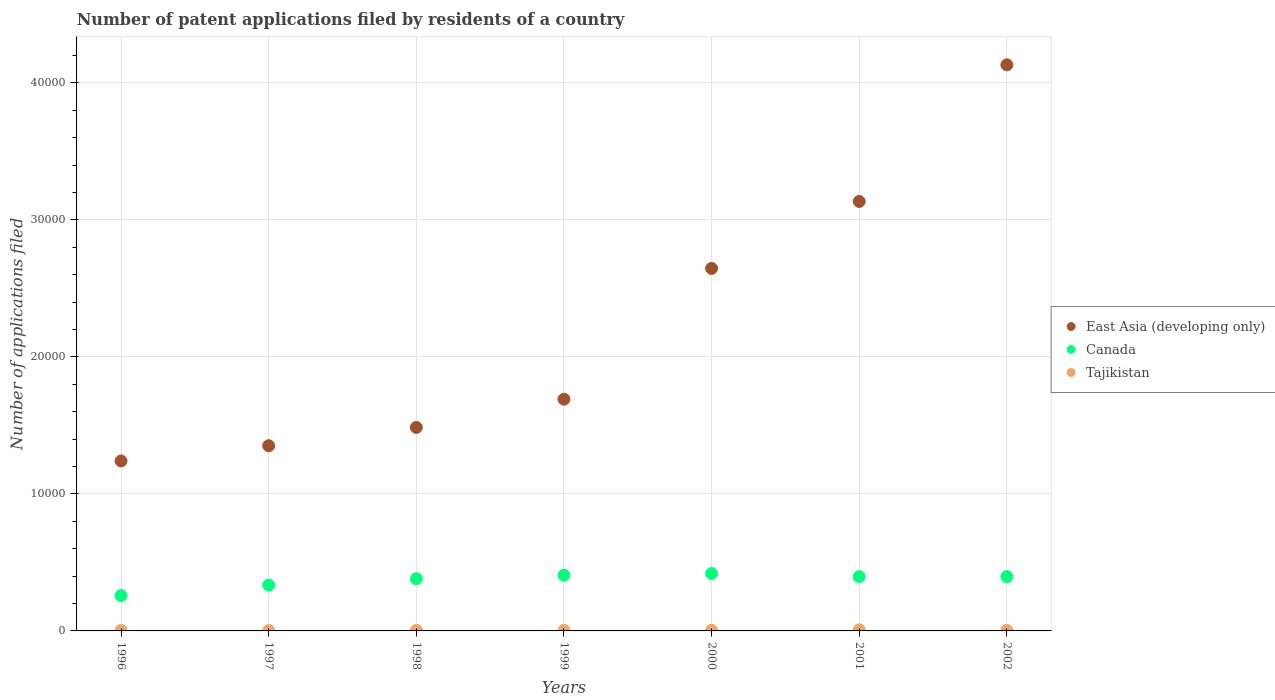How many different coloured dotlines are there?
Provide a succinct answer. 3. Is the number of dotlines equal to the number of legend labels?
Give a very brief answer. Yes. Across all years, what is the maximum number of applications filed in East Asia (developing only)?
Offer a terse response. 4.13e+04. Across all years, what is the minimum number of applications filed in East Asia (developing only)?
Offer a terse response. 1.24e+04. What is the total number of applications filed in Tajikistan in the graph?
Your answer should be very brief. 295. What is the difference between the number of applications filed in East Asia (developing only) in 1996 and that in 2001?
Provide a short and direct response. -1.89e+04. What is the difference between the number of applications filed in Tajikistan in 1997 and the number of applications filed in East Asia (developing only) in 1996?
Provide a succinct answer. -1.24e+04. What is the average number of applications filed in East Asia (developing only) per year?
Your response must be concise. 2.24e+04. In the year 1999, what is the difference between the number of applications filed in Tajikistan and number of applications filed in Canada?
Offer a terse response. -4023. What is the ratio of the number of applications filed in Canada in 1998 to that in 2001?
Your answer should be very brief. 0.96. Is the number of applications filed in Canada in 2000 less than that in 2002?
Ensure brevity in your answer.  No. What is the difference between the highest and the lowest number of applications filed in Canada?
Make the answer very short. 1604. Does the number of applications filed in Canada monotonically increase over the years?
Keep it short and to the point. No. Is the number of applications filed in Canada strictly greater than the number of applications filed in Tajikistan over the years?
Your answer should be very brief. Yes. Is the number of applications filed in East Asia (developing only) strictly less than the number of applications filed in Canada over the years?
Your response must be concise. No. How many dotlines are there?
Your response must be concise. 3. How many years are there in the graph?
Provide a succinct answer. 7. What is the difference between two consecutive major ticks on the Y-axis?
Keep it short and to the point. 10000. Are the values on the major ticks of Y-axis written in scientific E-notation?
Offer a very short reply. No. Does the graph contain grids?
Ensure brevity in your answer.  Yes. Where does the legend appear in the graph?
Offer a terse response. Center right. How many legend labels are there?
Give a very brief answer. 3. What is the title of the graph?
Your answer should be compact. Number of patent applications filed by residents of a country. What is the label or title of the X-axis?
Provide a succinct answer. Years. What is the label or title of the Y-axis?
Your answer should be very brief. Number of applications filed. What is the Number of applications filed in East Asia (developing only) in 1996?
Make the answer very short. 1.24e+04. What is the Number of applications filed of Canada in 1996?
Provide a succinct answer. 2583. What is the Number of applications filed of East Asia (developing only) in 1997?
Provide a short and direct response. 1.35e+04. What is the Number of applications filed of Canada in 1997?
Keep it short and to the point. 3344. What is the Number of applications filed in East Asia (developing only) in 1998?
Ensure brevity in your answer.  1.49e+04. What is the Number of applications filed in Canada in 1998?
Keep it short and to the point. 3809. What is the Number of applications filed of Tajikistan in 1998?
Your answer should be compact. 37. What is the Number of applications filed in East Asia (developing only) in 1999?
Offer a terse response. 1.69e+04. What is the Number of applications filed of Canada in 1999?
Keep it short and to the point. 4061. What is the Number of applications filed in Tajikistan in 1999?
Give a very brief answer. 38. What is the Number of applications filed in East Asia (developing only) in 2000?
Provide a succinct answer. 2.65e+04. What is the Number of applications filed in Canada in 2000?
Provide a succinct answer. 4187. What is the Number of applications filed in East Asia (developing only) in 2001?
Provide a succinct answer. 3.13e+04. What is the Number of applications filed in Canada in 2001?
Your answer should be very brief. 3963. What is the Number of applications filed in Tajikistan in 2001?
Offer a very short reply. 83. What is the Number of applications filed in East Asia (developing only) in 2002?
Ensure brevity in your answer.  4.13e+04. What is the Number of applications filed of Canada in 2002?
Give a very brief answer. 3959. What is the Number of applications filed in Tajikistan in 2002?
Your response must be concise. 39. Across all years, what is the maximum Number of applications filed of East Asia (developing only)?
Give a very brief answer. 4.13e+04. Across all years, what is the maximum Number of applications filed of Canada?
Ensure brevity in your answer.  4187. Across all years, what is the minimum Number of applications filed in East Asia (developing only)?
Provide a short and direct response. 1.24e+04. Across all years, what is the minimum Number of applications filed in Canada?
Your answer should be compact. 2583. Across all years, what is the minimum Number of applications filed in Tajikistan?
Ensure brevity in your answer.  23. What is the total Number of applications filed in East Asia (developing only) in the graph?
Provide a short and direct response. 1.57e+05. What is the total Number of applications filed of Canada in the graph?
Your response must be concise. 2.59e+04. What is the total Number of applications filed of Tajikistan in the graph?
Ensure brevity in your answer.  295. What is the difference between the Number of applications filed of East Asia (developing only) in 1996 and that in 1997?
Your answer should be compact. -1111. What is the difference between the Number of applications filed in Canada in 1996 and that in 1997?
Ensure brevity in your answer.  -761. What is the difference between the Number of applications filed in East Asia (developing only) in 1996 and that in 1998?
Your answer should be compact. -2446. What is the difference between the Number of applications filed in Canada in 1996 and that in 1998?
Your response must be concise. -1226. What is the difference between the Number of applications filed of Tajikistan in 1996 and that in 1998?
Your response must be concise. -7. What is the difference between the Number of applications filed in East Asia (developing only) in 1996 and that in 1999?
Your response must be concise. -4507. What is the difference between the Number of applications filed in Canada in 1996 and that in 1999?
Your answer should be very brief. -1478. What is the difference between the Number of applications filed in Tajikistan in 1996 and that in 1999?
Provide a short and direct response. -8. What is the difference between the Number of applications filed in East Asia (developing only) in 1996 and that in 2000?
Offer a very short reply. -1.41e+04. What is the difference between the Number of applications filed of Canada in 1996 and that in 2000?
Offer a terse response. -1604. What is the difference between the Number of applications filed of Tajikistan in 1996 and that in 2000?
Offer a terse response. -15. What is the difference between the Number of applications filed in East Asia (developing only) in 1996 and that in 2001?
Give a very brief answer. -1.89e+04. What is the difference between the Number of applications filed of Canada in 1996 and that in 2001?
Offer a very short reply. -1380. What is the difference between the Number of applications filed of Tajikistan in 1996 and that in 2001?
Make the answer very short. -53. What is the difference between the Number of applications filed of East Asia (developing only) in 1996 and that in 2002?
Provide a succinct answer. -2.89e+04. What is the difference between the Number of applications filed of Canada in 1996 and that in 2002?
Ensure brevity in your answer.  -1376. What is the difference between the Number of applications filed in East Asia (developing only) in 1997 and that in 1998?
Your answer should be compact. -1335. What is the difference between the Number of applications filed of Canada in 1997 and that in 1998?
Offer a terse response. -465. What is the difference between the Number of applications filed of East Asia (developing only) in 1997 and that in 1999?
Ensure brevity in your answer.  -3396. What is the difference between the Number of applications filed in Canada in 1997 and that in 1999?
Your response must be concise. -717. What is the difference between the Number of applications filed of Tajikistan in 1997 and that in 1999?
Provide a short and direct response. -15. What is the difference between the Number of applications filed of East Asia (developing only) in 1997 and that in 2000?
Your response must be concise. -1.29e+04. What is the difference between the Number of applications filed of Canada in 1997 and that in 2000?
Make the answer very short. -843. What is the difference between the Number of applications filed in Tajikistan in 1997 and that in 2000?
Your answer should be compact. -22. What is the difference between the Number of applications filed of East Asia (developing only) in 1997 and that in 2001?
Provide a succinct answer. -1.78e+04. What is the difference between the Number of applications filed in Canada in 1997 and that in 2001?
Provide a succinct answer. -619. What is the difference between the Number of applications filed of Tajikistan in 1997 and that in 2001?
Provide a short and direct response. -60. What is the difference between the Number of applications filed of East Asia (developing only) in 1997 and that in 2002?
Make the answer very short. -2.78e+04. What is the difference between the Number of applications filed in Canada in 1997 and that in 2002?
Provide a short and direct response. -615. What is the difference between the Number of applications filed in Tajikistan in 1997 and that in 2002?
Ensure brevity in your answer.  -16. What is the difference between the Number of applications filed in East Asia (developing only) in 1998 and that in 1999?
Provide a short and direct response. -2061. What is the difference between the Number of applications filed in Canada in 1998 and that in 1999?
Your answer should be very brief. -252. What is the difference between the Number of applications filed in East Asia (developing only) in 1998 and that in 2000?
Provide a short and direct response. -1.16e+04. What is the difference between the Number of applications filed of Canada in 1998 and that in 2000?
Provide a succinct answer. -378. What is the difference between the Number of applications filed of East Asia (developing only) in 1998 and that in 2001?
Your answer should be very brief. -1.65e+04. What is the difference between the Number of applications filed of Canada in 1998 and that in 2001?
Ensure brevity in your answer.  -154. What is the difference between the Number of applications filed in Tajikistan in 1998 and that in 2001?
Keep it short and to the point. -46. What is the difference between the Number of applications filed of East Asia (developing only) in 1998 and that in 2002?
Offer a very short reply. -2.65e+04. What is the difference between the Number of applications filed in Canada in 1998 and that in 2002?
Offer a very short reply. -150. What is the difference between the Number of applications filed in Tajikistan in 1998 and that in 2002?
Provide a short and direct response. -2. What is the difference between the Number of applications filed in East Asia (developing only) in 1999 and that in 2000?
Offer a terse response. -9545. What is the difference between the Number of applications filed in Canada in 1999 and that in 2000?
Your answer should be very brief. -126. What is the difference between the Number of applications filed of Tajikistan in 1999 and that in 2000?
Provide a succinct answer. -7. What is the difference between the Number of applications filed in East Asia (developing only) in 1999 and that in 2001?
Offer a terse response. -1.44e+04. What is the difference between the Number of applications filed in Canada in 1999 and that in 2001?
Your answer should be very brief. 98. What is the difference between the Number of applications filed in Tajikistan in 1999 and that in 2001?
Your answer should be very brief. -45. What is the difference between the Number of applications filed of East Asia (developing only) in 1999 and that in 2002?
Offer a very short reply. -2.44e+04. What is the difference between the Number of applications filed of Canada in 1999 and that in 2002?
Ensure brevity in your answer.  102. What is the difference between the Number of applications filed in East Asia (developing only) in 2000 and that in 2001?
Keep it short and to the point. -4890. What is the difference between the Number of applications filed of Canada in 2000 and that in 2001?
Offer a very short reply. 224. What is the difference between the Number of applications filed of Tajikistan in 2000 and that in 2001?
Offer a very short reply. -38. What is the difference between the Number of applications filed in East Asia (developing only) in 2000 and that in 2002?
Provide a succinct answer. -1.49e+04. What is the difference between the Number of applications filed in Canada in 2000 and that in 2002?
Ensure brevity in your answer.  228. What is the difference between the Number of applications filed in Tajikistan in 2000 and that in 2002?
Your response must be concise. 6. What is the difference between the Number of applications filed of East Asia (developing only) in 2001 and that in 2002?
Your answer should be very brief. -9968. What is the difference between the Number of applications filed in Tajikistan in 2001 and that in 2002?
Your response must be concise. 44. What is the difference between the Number of applications filed of East Asia (developing only) in 1996 and the Number of applications filed of Canada in 1997?
Keep it short and to the point. 9062. What is the difference between the Number of applications filed of East Asia (developing only) in 1996 and the Number of applications filed of Tajikistan in 1997?
Your answer should be compact. 1.24e+04. What is the difference between the Number of applications filed in Canada in 1996 and the Number of applications filed in Tajikistan in 1997?
Provide a short and direct response. 2560. What is the difference between the Number of applications filed in East Asia (developing only) in 1996 and the Number of applications filed in Canada in 1998?
Ensure brevity in your answer.  8597. What is the difference between the Number of applications filed of East Asia (developing only) in 1996 and the Number of applications filed of Tajikistan in 1998?
Ensure brevity in your answer.  1.24e+04. What is the difference between the Number of applications filed of Canada in 1996 and the Number of applications filed of Tajikistan in 1998?
Give a very brief answer. 2546. What is the difference between the Number of applications filed of East Asia (developing only) in 1996 and the Number of applications filed of Canada in 1999?
Your answer should be very brief. 8345. What is the difference between the Number of applications filed of East Asia (developing only) in 1996 and the Number of applications filed of Tajikistan in 1999?
Provide a succinct answer. 1.24e+04. What is the difference between the Number of applications filed in Canada in 1996 and the Number of applications filed in Tajikistan in 1999?
Make the answer very short. 2545. What is the difference between the Number of applications filed of East Asia (developing only) in 1996 and the Number of applications filed of Canada in 2000?
Give a very brief answer. 8219. What is the difference between the Number of applications filed in East Asia (developing only) in 1996 and the Number of applications filed in Tajikistan in 2000?
Your answer should be very brief. 1.24e+04. What is the difference between the Number of applications filed of Canada in 1996 and the Number of applications filed of Tajikistan in 2000?
Offer a terse response. 2538. What is the difference between the Number of applications filed in East Asia (developing only) in 1996 and the Number of applications filed in Canada in 2001?
Your answer should be very brief. 8443. What is the difference between the Number of applications filed in East Asia (developing only) in 1996 and the Number of applications filed in Tajikistan in 2001?
Offer a terse response. 1.23e+04. What is the difference between the Number of applications filed of Canada in 1996 and the Number of applications filed of Tajikistan in 2001?
Your response must be concise. 2500. What is the difference between the Number of applications filed of East Asia (developing only) in 1996 and the Number of applications filed of Canada in 2002?
Your answer should be compact. 8447. What is the difference between the Number of applications filed in East Asia (developing only) in 1996 and the Number of applications filed in Tajikistan in 2002?
Your response must be concise. 1.24e+04. What is the difference between the Number of applications filed of Canada in 1996 and the Number of applications filed of Tajikistan in 2002?
Provide a short and direct response. 2544. What is the difference between the Number of applications filed in East Asia (developing only) in 1997 and the Number of applications filed in Canada in 1998?
Offer a very short reply. 9708. What is the difference between the Number of applications filed of East Asia (developing only) in 1997 and the Number of applications filed of Tajikistan in 1998?
Provide a short and direct response. 1.35e+04. What is the difference between the Number of applications filed in Canada in 1997 and the Number of applications filed in Tajikistan in 1998?
Offer a very short reply. 3307. What is the difference between the Number of applications filed of East Asia (developing only) in 1997 and the Number of applications filed of Canada in 1999?
Give a very brief answer. 9456. What is the difference between the Number of applications filed in East Asia (developing only) in 1997 and the Number of applications filed in Tajikistan in 1999?
Your response must be concise. 1.35e+04. What is the difference between the Number of applications filed of Canada in 1997 and the Number of applications filed of Tajikistan in 1999?
Ensure brevity in your answer.  3306. What is the difference between the Number of applications filed of East Asia (developing only) in 1997 and the Number of applications filed of Canada in 2000?
Give a very brief answer. 9330. What is the difference between the Number of applications filed of East Asia (developing only) in 1997 and the Number of applications filed of Tajikistan in 2000?
Make the answer very short. 1.35e+04. What is the difference between the Number of applications filed of Canada in 1997 and the Number of applications filed of Tajikistan in 2000?
Ensure brevity in your answer.  3299. What is the difference between the Number of applications filed in East Asia (developing only) in 1997 and the Number of applications filed in Canada in 2001?
Your response must be concise. 9554. What is the difference between the Number of applications filed in East Asia (developing only) in 1997 and the Number of applications filed in Tajikistan in 2001?
Your answer should be compact. 1.34e+04. What is the difference between the Number of applications filed in Canada in 1997 and the Number of applications filed in Tajikistan in 2001?
Provide a succinct answer. 3261. What is the difference between the Number of applications filed in East Asia (developing only) in 1997 and the Number of applications filed in Canada in 2002?
Your response must be concise. 9558. What is the difference between the Number of applications filed in East Asia (developing only) in 1997 and the Number of applications filed in Tajikistan in 2002?
Your answer should be compact. 1.35e+04. What is the difference between the Number of applications filed of Canada in 1997 and the Number of applications filed of Tajikistan in 2002?
Make the answer very short. 3305. What is the difference between the Number of applications filed in East Asia (developing only) in 1998 and the Number of applications filed in Canada in 1999?
Keep it short and to the point. 1.08e+04. What is the difference between the Number of applications filed in East Asia (developing only) in 1998 and the Number of applications filed in Tajikistan in 1999?
Ensure brevity in your answer.  1.48e+04. What is the difference between the Number of applications filed in Canada in 1998 and the Number of applications filed in Tajikistan in 1999?
Your answer should be very brief. 3771. What is the difference between the Number of applications filed in East Asia (developing only) in 1998 and the Number of applications filed in Canada in 2000?
Your answer should be compact. 1.07e+04. What is the difference between the Number of applications filed in East Asia (developing only) in 1998 and the Number of applications filed in Tajikistan in 2000?
Offer a terse response. 1.48e+04. What is the difference between the Number of applications filed of Canada in 1998 and the Number of applications filed of Tajikistan in 2000?
Your answer should be very brief. 3764. What is the difference between the Number of applications filed in East Asia (developing only) in 1998 and the Number of applications filed in Canada in 2001?
Give a very brief answer. 1.09e+04. What is the difference between the Number of applications filed in East Asia (developing only) in 1998 and the Number of applications filed in Tajikistan in 2001?
Provide a succinct answer. 1.48e+04. What is the difference between the Number of applications filed of Canada in 1998 and the Number of applications filed of Tajikistan in 2001?
Offer a very short reply. 3726. What is the difference between the Number of applications filed of East Asia (developing only) in 1998 and the Number of applications filed of Canada in 2002?
Give a very brief answer. 1.09e+04. What is the difference between the Number of applications filed of East Asia (developing only) in 1998 and the Number of applications filed of Tajikistan in 2002?
Provide a short and direct response. 1.48e+04. What is the difference between the Number of applications filed in Canada in 1998 and the Number of applications filed in Tajikistan in 2002?
Provide a short and direct response. 3770. What is the difference between the Number of applications filed in East Asia (developing only) in 1999 and the Number of applications filed in Canada in 2000?
Your answer should be very brief. 1.27e+04. What is the difference between the Number of applications filed in East Asia (developing only) in 1999 and the Number of applications filed in Tajikistan in 2000?
Keep it short and to the point. 1.69e+04. What is the difference between the Number of applications filed of Canada in 1999 and the Number of applications filed of Tajikistan in 2000?
Provide a succinct answer. 4016. What is the difference between the Number of applications filed in East Asia (developing only) in 1999 and the Number of applications filed in Canada in 2001?
Your response must be concise. 1.30e+04. What is the difference between the Number of applications filed in East Asia (developing only) in 1999 and the Number of applications filed in Tajikistan in 2001?
Ensure brevity in your answer.  1.68e+04. What is the difference between the Number of applications filed of Canada in 1999 and the Number of applications filed of Tajikistan in 2001?
Your answer should be very brief. 3978. What is the difference between the Number of applications filed in East Asia (developing only) in 1999 and the Number of applications filed in Canada in 2002?
Offer a very short reply. 1.30e+04. What is the difference between the Number of applications filed in East Asia (developing only) in 1999 and the Number of applications filed in Tajikistan in 2002?
Offer a terse response. 1.69e+04. What is the difference between the Number of applications filed in Canada in 1999 and the Number of applications filed in Tajikistan in 2002?
Your answer should be compact. 4022. What is the difference between the Number of applications filed of East Asia (developing only) in 2000 and the Number of applications filed of Canada in 2001?
Offer a very short reply. 2.25e+04. What is the difference between the Number of applications filed of East Asia (developing only) in 2000 and the Number of applications filed of Tajikistan in 2001?
Your response must be concise. 2.64e+04. What is the difference between the Number of applications filed in Canada in 2000 and the Number of applications filed in Tajikistan in 2001?
Your response must be concise. 4104. What is the difference between the Number of applications filed of East Asia (developing only) in 2000 and the Number of applications filed of Canada in 2002?
Your response must be concise. 2.25e+04. What is the difference between the Number of applications filed of East Asia (developing only) in 2000 and the Number of applications filed of Tajikistan in 2002?
Give a very brief answer. 2.64e+04. What is the difference between the Number of applications filed in Canada in 2000 and the Number of applications filed in Tajikistan in 2002?
Offer a terse response. 4148. What is the difference between the Number of applications filed of East Asia (developing only) in 2001 and the Number of applications filed of Canada in 2002?
Offer a very short reply. 2.74e+04. What is the difference between the Number of applications filed of East Asia (developing only) in 2001 and the Number of applications filed of Tajikistan in 2002?
Your answer should be compact. 3.13e+04. What is the difference between the Number of applications filed in Canada in 2001 and the Number of applications filed in Tajikistan in 2002?
Your response must be concise. 3924. What is the average Number of applications filed in East Asia (developing only) per year?
Your answer should be compact. 2.24e+04. What is the average Number of applications filed in Canada per year?
Provide a succinct answer. 3700.86. What is the average Number of applications filed of Tajikistan per year?
Provide a succinct answer. 42.14. In the year 1996, what is the difference between the Number of applications filed in East Asia (developing only) and Number of applications filed in Canada?
Your answer should be compact. 9823. In the year 1996, what is the difference between the Number of applications filed of East Asia (developing only) and Number of applications filed of Tajikistan?
Offer a very short reply. 1.24e+04. In the year 1996, what is the difference between the Number of applications filed in Canada and Number of applications filed in Tajikistan?
Ensure brevity in your answer.  2553. In the year 1997, what is the difference between the Number of applications filed of East Asia (developing only) and Number of applications filed of Canada?
Provide a succinct answer. 1.02e+04. In the year 1997, what is the difference between the Number of applications filed in East Asia (developing only) and Number of applications filed in Tajikistan?
Provide a short and direct response. 1.35e+04. In the year 1997, what is the difference between the Number of applications filed in Canada and Number of applications filed in Tajikistan?
Provide a short and direct response. 3321. In the year 1998, what is the difference between the Number of applications filed of East Asia (developing only) and Number of applications filed of Canada?
Offer a terse response. 1.10e+04. In the year 1998, what is the difference between the Number of applications filed of East Asia (developing only) and Number of applications filed of Tajikistan?
Offer a terse response. 1.48e+04. In the year 1998, what is the difference between the Number of applications filed of Canada and Number of applications filed of Tajikistan?
Give a very brief answer. 3772. In the year 1999, what is the difference between the Number of applications filed of East Asia (developing only) and Number of applications filed of Canada?
Offer a terse response. 1.29e+04. In the year 1999, what is the difference between the Number of applications filed of East Asia (developing only) and Number of applications filed of Tajikistan?
Your response must be concise. 1.69e+04. In the year 1999, what is the difference between the Number of applications filed in Canada and Number of applications filed in Tajikistan?
Offer a terse response. 4023. In the year 2000, what is the difference between the Number of applications filed of East Asia (developing only) and Number of applications filed of Canada?
Ensure brevity in your answer.  2.23e+04. In the year 2000, what is the difference between the Number of applications filed of East Asia (developing only) and Number of applications filed of Tajikistan?
Keep it short and to the point. 2.64e+04. In the year 2000, what is the difference between the Number of applications filed of Canada and Number of applications filed of Tajikistan?
Offer a very short reply. 4142. In the year 2001, what is the difference between the Number of applications filed in East Asia (developing only) and Number of applications filed in Canada?
Your answer should be compact. 2.74e+04. In the year 2001, what is the difference between the Number of applications filed in East Asia (developing only) and Number of applications filed in Tajikistan?
Offer a very short reply. 3.13e+04. In the year 2001, what is the difference between the Number of applications filed in Canada and Number of applications filed in Tajikistan?
Keep it short and to the point. 3880. In the year 2002, what is the difference between the Number of applications filed in East Asia (developing only) and Number of applications filed in Canada?
Your answer should be compact. 3.74e+04. In the year 2002, what is the difference between the Number of applications filed in East Asia (developing only) and Number of applications filed in Tajikistan?
Ensure brevity in your answer.  4.13e+04. In the year 2002, what is the difference between the Number of applications filed in Canada and Number of applications filed in Tajikistan?
Offer a terse response. 3920. What is the ratio of the Number of applications filed in East Asia (developing only) in 1996 to that in 1997?
Make the answer very short. 0.92. What is the ratio of the Number of applications filed in Canada in 1996 to that in 1997?
Give a very brief answer. 0.77. What is the ratio of the Number of applications filed of Tajikistan in 1996 to that in 1997?
Your response must be concise. 1.3. What is the ratio of the Number of applications filed of East Asia (developing only) in 1996 to that in 1998?
Give a very brief answer. 0.84. What is the ratio of the Number of applications filed in Canada in 1996 to that in 1998?
Make the answer very short. 0.68. What is the ratio of the Number of applications filed in Tajikistan in 1996 to that in 1998?
Give a very brief answer. 0.81. What is the ratio of the Number of applications filed of East Asia (developing only) in 1996 to that in 1999?
Your answer should be compact. 0.73. What is the ratio of the Number of applications filed of Canada in 1996 to that in 1999?
Offer a very short reply. 0.64. What is the ratio of the Number of applications filed in Tajikistan in 1996 to that in 1999?
Give a very brief answer. 0.79. What is the ratio of the Number of applications filed of East Asia (developing only) in 1996 to that in 2000?
Provide a succinct answer. 0.47. What is the ratio of the Number of applications filed in Canada in 1996 to that in 2000?
Your answer should be very brief. 0.62. What is the ratio of the Number of applications filed of Tajikistan in 1996 to that in 2000?
Provide a short and direct response. 0.67. What is the ratio of the Number of applications filed of East Asia (developing only) in 1996 to that in 2001?
Your answer should be compact. 0.4. What is the ratio of the Number of applications filed in Canada in 1996 to that in 2001?
Give a very brief answer. 0.65. What is the ratio of the Number of applications filed in Tajikistan in 1996 to that in 2001?
Offer a terse response. 0.36. What is the ratio of the Number of applications filed in East Asia (developing only) in 1996 to that in 2002?
Your answer should be compact. 0.3. What is the ratio of the Number of applications filed in Canada in 1996 to that in 2002?
Make the answer very short. 0.65. What is the ratio of the Number of applications filed in Tajikistan in 1996 to that in 2002?
Provide a succinct answer. 0.77. What is the ratio of the Number of applications filed in East Asia (developing only) in 1997 to that in 1998?
Provide a succinct answer. 0.91. What is the ratio of the Number of applications filed in Canada in 1997 to that in 1998?
Give a very brief answer. 0.88. What is the ratio of the Number of applications filed of Tajikistan in 1997 to that in 1998?
Ensure brevity in your answer.  0.62. What is the ratio of the Number of applications filed in East Asia (developing only) in 1997 to that in 1999?
Offer a very short reply. 0.8. What is the ratio of the Number of applications filed in Canada in 1997 to that in 1999?
Offer a very short reply. 0.82. What is the ratio of the Number of applications filed of Tajikistan in 1997 to that in 1999?
Your response must be concise. 0.61. What is the ratio of the Number of applications filed in East Asia (developing only) in 1997 to that in 2000?
Ensure brevity in your answer.  0.51. What is the ratio of the Number of applications filed of Canada in 1997 to that in 2000?
Your answer should be very brief. 0.8. What is the ratio of the Number of applications filed of Tajikistan in 1997 to that in 2000?
Provide a succinct answer. 0.51. What is the ratio of the Number of applications filed in East Asia (developing only) in 1997 to that in 2001?
Keep it short and to the point. 0.43. What is the ratio of the Number of applications filed of Canada in 1997 to that in 2001?
Offer a terse response. 0.84. What is the ratio of the Number of applications filed in Tajikistan in 1997 to that in 2001?
Provide a succinct answer. 0.28. What is the ratio of the Number of applications filed in East Asia (developing only) in 1997 to that in 2002?
Offer a very short reply. 0.33. What is the ratio of the Number of applications filed in Canada in 1997 to that in 2002?
Offer a very short reply. 0.84. What is the ratio of the Number of applications filed in Tajikistan in 1997 to that in 2002?
Your answer should be very brief. 0.59. What is the ratio of the Number of applications filed of East Asia (developing only) in 1998 to that in 1999?
Provide a short and direct response. 0.88. What is the ratio of the Number of applications filed in Canada in 1998 to that in 1999?
Your response must be concise. 0.94. What is the ratio of the Number of applications filed of Tajikistan in 1998 to that in 1999?
Offer a terse response. 0.97. What is the ratio of the Number of applications filed in East Asia (developing only) in 1998 to that in 2000?
Your answer should be very brief. 0.56. What is the ratio of the Number of applications filed of Canada in 1998 to that in 2000?
Offer a terse response. 0.91. What is the ratio of the Number of applications filed in Tajikistan in 1998 to that in 2000?
Offer a terse response. 0.82. What is the ratio of the Number of applications filed in East Asia (developing only) in 1998 to that in 2001?
Keep it short and to the point. 0.47. What is the ratio of the Number of applications filed of Canada in 1998 to that in 2001?
Offer a very short reply. 0.96. What is the ratio of the Number of applications filed in Tajikistan in 1998 to that in 2001?
Ensure brevity in your answer.  0.45. What is the ratio of the Number of applications filed of East Asia (developing only) in 1998 to that in 2002?
Keep it short and to the point. 0.36. What is the ratio of the Number of applications filed in Canada in 1998 to that in 2002?
Ensure brevity in your answer.  0.96. What is the ratio of the Number of applications filed in Tajikistan in 1998 to that in 2002?
Give a very brief answer. 0.95. What is the ratio of the Number of applications filed in East Asia (developing only) in 1999 to that in 2000?
Ensure brevity in your answer.  0.64. What is the ratio of the Number of applications filed in Canada in 1999 to that in 2000?
Provide a succinct answer. 0.97. What is the ratio of the Number of applications filed in Tajikistan in 1999 to that in 2000?
Give a very brief answer. 0.84. What is the ratio of the Number of applications filed of East Asia (developing only) in 1999 to that in 2001?
Provide a succinct answer. 0.54. What is the ratio of the Number of applications filed in Canada in 1999 to that in 2001?
Your answer should be very brief. 1.02. What is the ratio of the Number of applications filed in Tajikistan in 1999 to that in 2001?
Your response must be concise. 0.46. What is the ratio of the Number of applications filed in East Asia (developing only) in 1999 to that in 2002?
Provide a short and direct response. 0.41. What is the ratio of the Number of applications filed in Canada in 1999 to that in 2002?
Make the answer very short. 1.03. What is the ratio of the Number of applications filed in Tajikistan in 1999 to that in 2002?
Provide a short and direct response. 0.97. What is the ratio of the Number of applications filed in East Asia (developing only) in 2000 to that in 2001?
Keep it short and to the point. 0.84. What is the ratio of the Number of applications filed of Canada in 2000 to that in 2001?
Offer a terse response. 1.06. What is the ratio of the Number of applications filed of Tajikistan in 2000 to that in 2001?
Your answer should be compact. 0.54. What is the ratio of the Number of applications filed in East Asia (developing only) in 2000 to that in 2002?
Offer a terse response. 0.64. What is the ratio of the Number of applications filed of Canada in 2000 to that in 2002?
Your answer should be very brief. 1.06. What is the ratio of the Number of applications filed of Tajikistan in 2000 to that in 2002?
Your answer should be compact. 1.15. What is the ratio of the Number of applications filed in East Asia (developing only) in 2001 to that in 2002?
Ensure brevity in your answer.  0.76. What is the ratio of the Number of applications filed in Tajikistan in 2001 to that in 2002?
Make the answer very short. 2.13. What is the difference between the highest and the second highest Number of applications filed of East Asia (developing only)?
Your answer should be very brief. 9968. What is the difference between the highest and the second highest Number of applications filed of Canada?
Offer a terse response. 126. What is the difference between the highest and the second highest Number of applications filed of Tajikistan?
Your answer should be very brief. 38. What is the difference between the highest and the lowest Number of applications filed of East Asia (developing only)?
Offer a terse response. 2.89e+04. What is the difference between the highest and the lowest Number of applications filed of Canada?
Your response must be concise. 1604. 